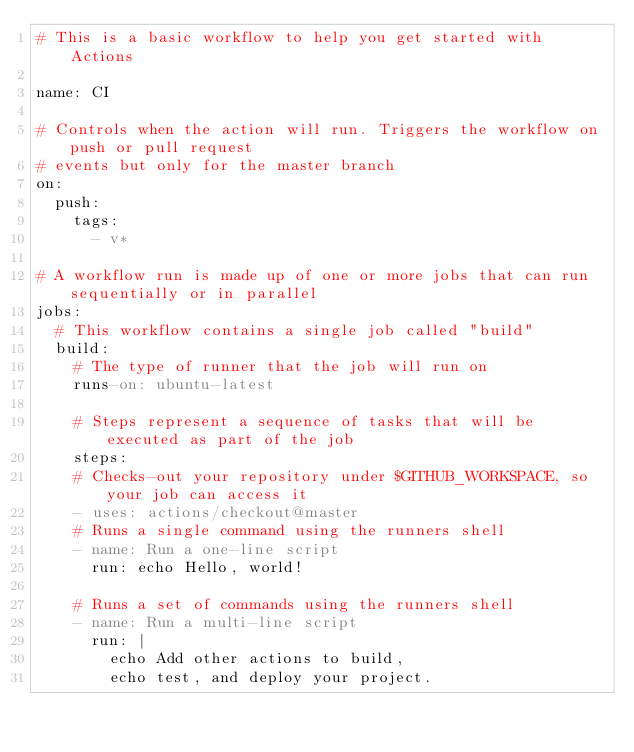<code> <loc_0><loc_0><loc_500><loc_500><_YAML_># This is a basic workflow to help you get started with Actions

name: CI

# Controls when the action will run. Triggers the workflow on push or pull request
# events but only for the master branch
on:
  push:
    tags:
      - v*

# A workflow run is made up of one or more jobs that can run sequentially or in parallel
jobs:
  # This workflow contains a single job called "build"
  build:
    # The type of runner that the job will run on
    runs-on: ubuntu-latest

    # Steps represent a sequence of tasks that will be executed as part of the job
    steps:
    # Checks-out your repository under $GITHUB_WORKSPACE, so your job can access it
    - uses: actions/checkout@master
    # Runs a single command using the runners shell
    - name: Run a one-line script
      run: echo Hello, world!

    # Runs a set of commands using the runners shell
    - name: Run a multi-line script
      run: |
        echo Add other actions to build,
        echo test, and deploy your project.
</code> 